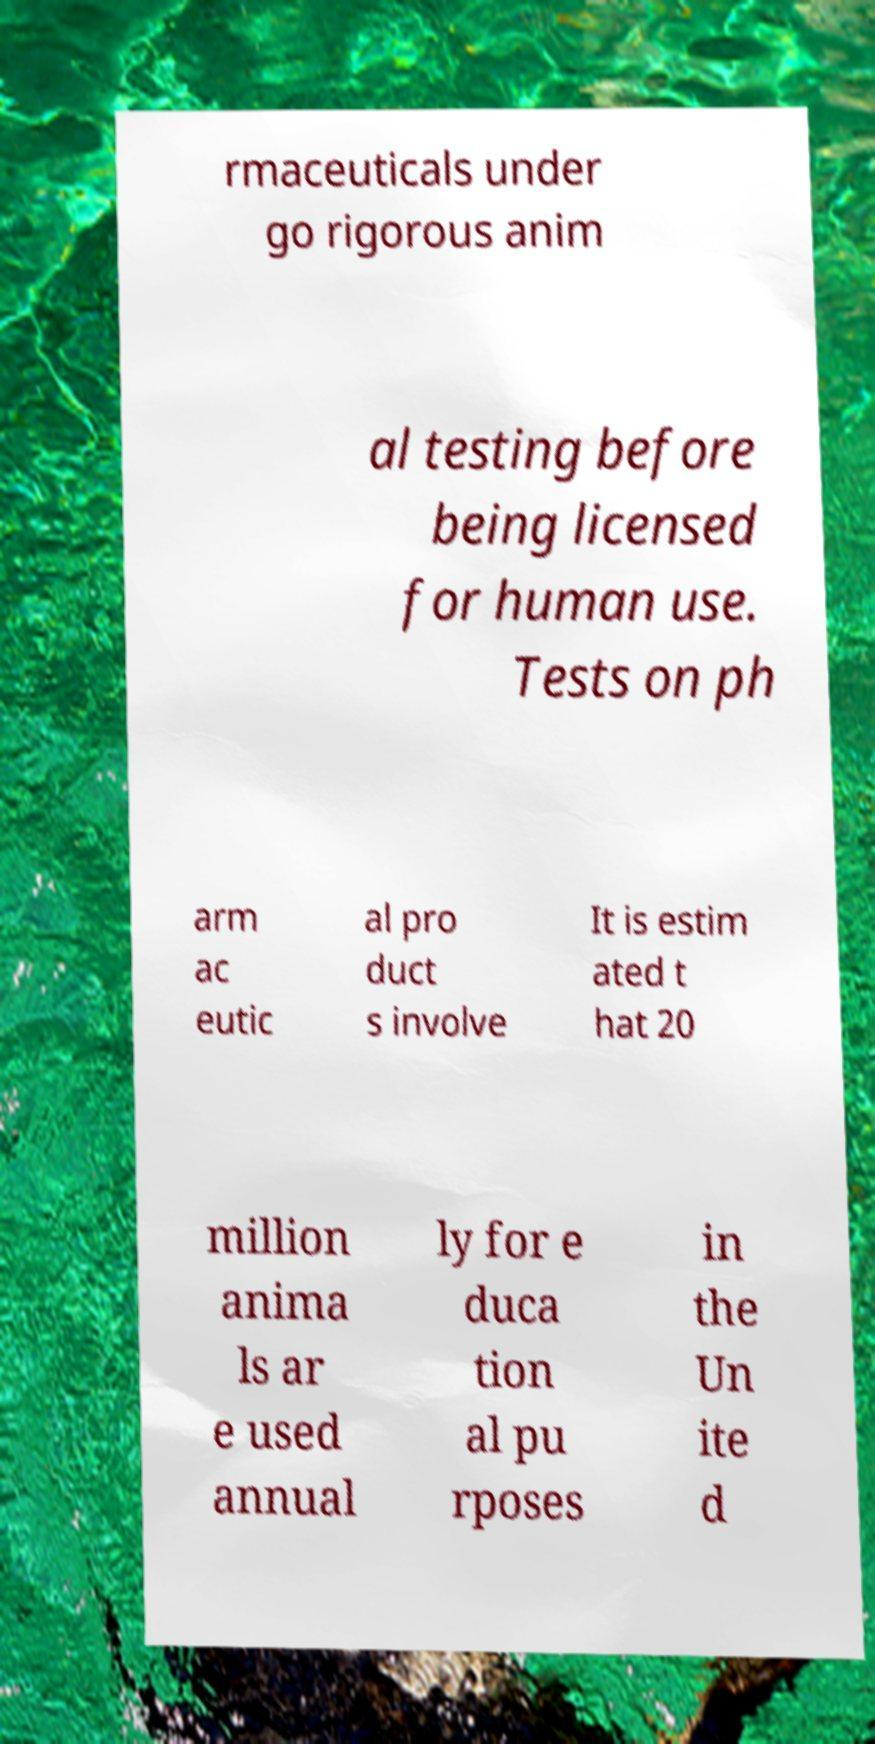Can you read and provide the text displayed in the image?This photo seems to have some interesting text. Can you extract and type it out for me? rmaceuticals under go rigorous anim al testing before being licensed for human use. Tests on ph arm ac eutic al pro duct s involve It is estim ated t hat 20 million anima ls ar e used annual ly for e duca tion al pu rposes in the Un ite d 